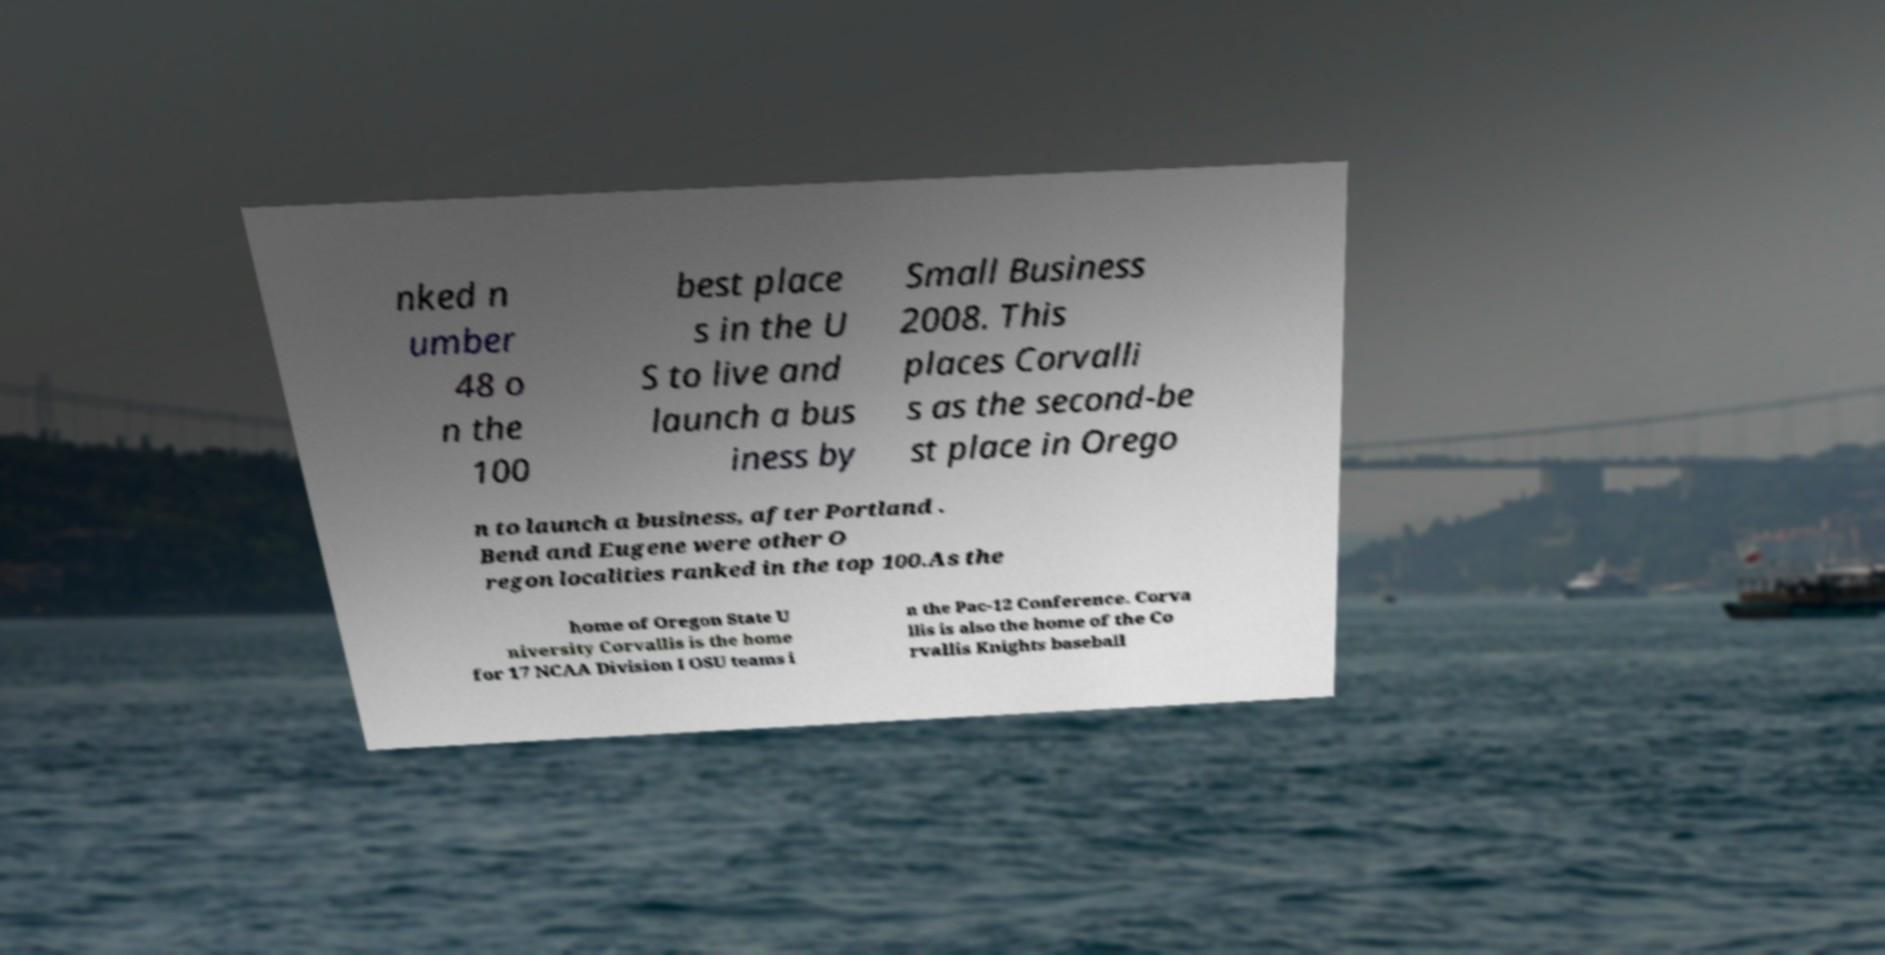There's text embedded in this image that I need extracted. Can you transcribe it verbatim? nked n umber 48 o n the 100 best place s in the U S to live and launch a bus iness by Small Business 2008. This places Corvalli s as the second-be st place in Orego n to launch a business, after Portland . Bend and Eugene were other O regon localities ranked in the top 100.As the home of Oregon State U niversity Corvallis is the home for 17 NCAA Division I OSU teams i n the Pac-12 Conference. Corva llis is also the home of the Co rvallis Knights baseball 